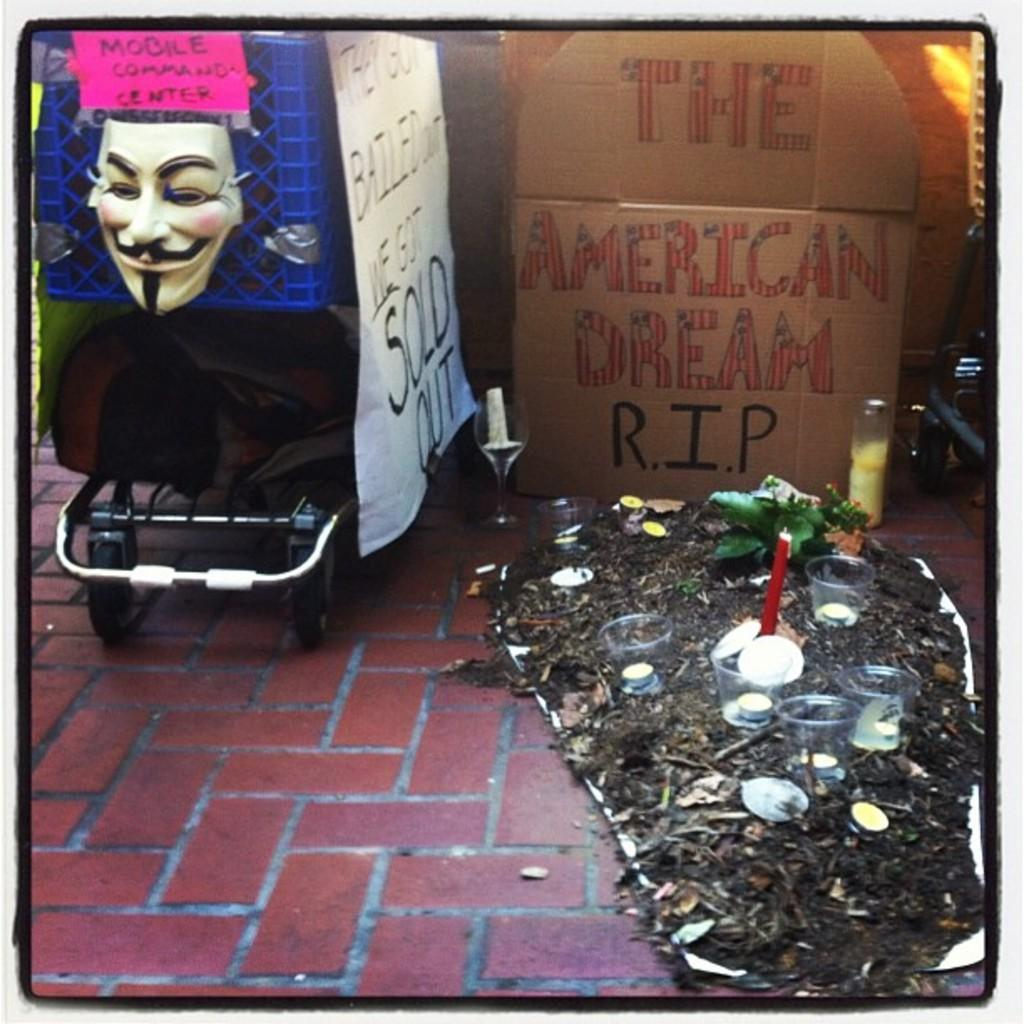What is the main object in the center of the image? There is a wheel cart in the center of the image. What can be seen in the image besides the wheel cart? There is a bag, a face mask, banners, glasses, and dry leaves present in the image. What might be used for vision correction in the image? Glasses are visible in the image for vision correction. What type of decoration or signage is present in the image? Banners are present in the image, which might be used for decoration or signage. Who is the manager of the dock in the image? There is no dock present in the image, so it is not possible to determine who the manager might be. 